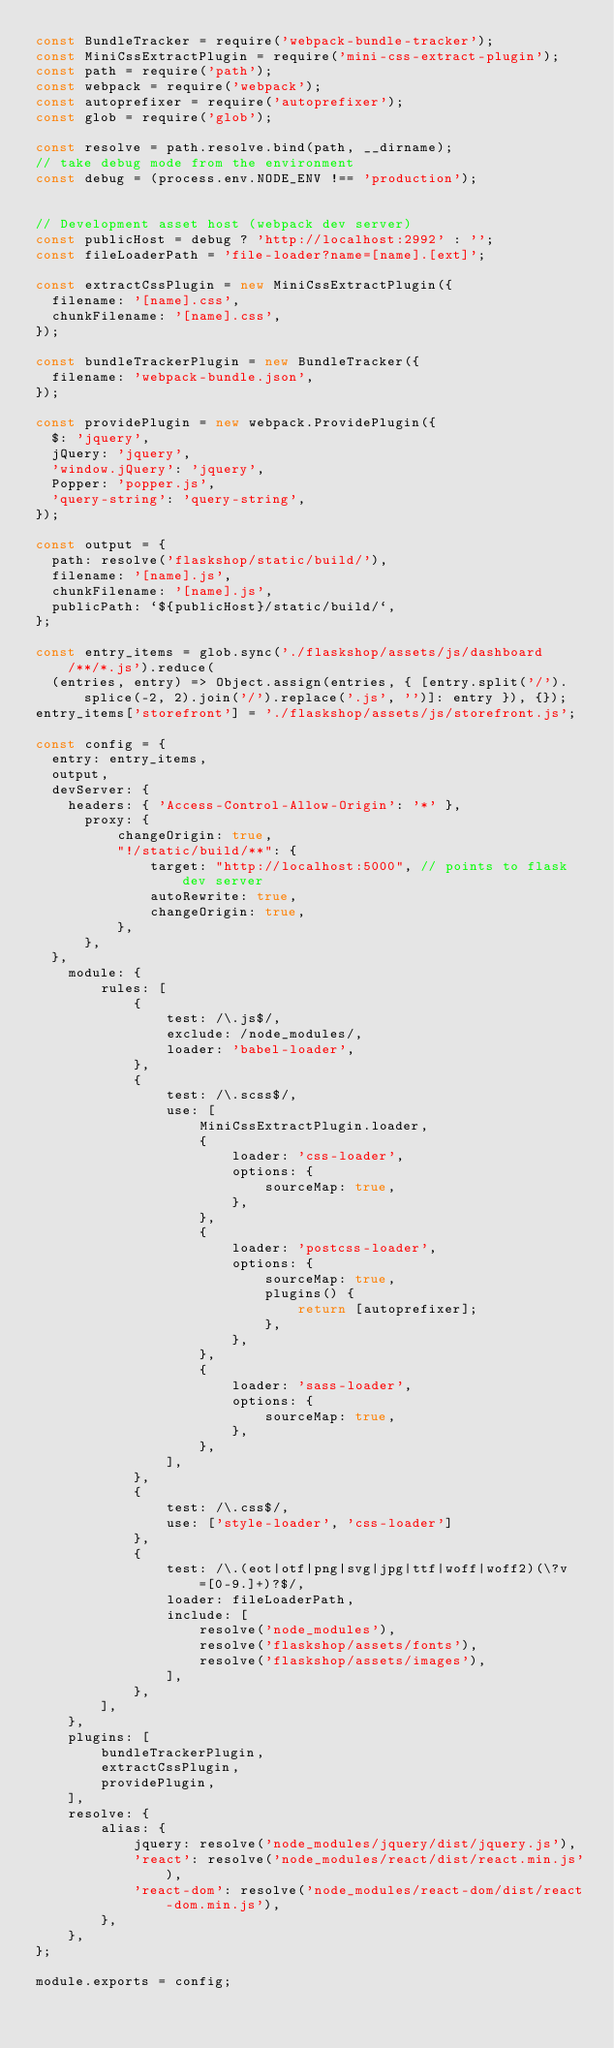Convert code to text. <code><loc_0><loc_0><loc_500><loc_500><_JavaScript_>const BundleTracker = require('webpack-bundle-tracker');
const MiniCssExtractPlugin = require('mini-css-extract-plugin');
const path = require('path');
const webpack = require('webpack');
const autoprefixer = require('autoprefixer');
const glob = require('glob');

const resolve = path.resolve.bind(path, __dirname);
// take debug mode from the environment
const debug = (process.env.NODE_ENV !== 'production');


// Development asset host (webpack dev server)
const publicHost = debug ? 'http://localhost:2992' : '';
const fileLoaderPath = 'file-loader?name=[name].[ext]';

const extractCssPlugin = new MiniCssExtractPlugin({
  filename: '[name].css',
  chunkFilename: '[name].css',
});

const bundleTrackerPlugin = new BundleTracker({
  filename: 'webpack-bundle.json',
});

const providePlugin = new webpack.ProvidePlugin({
  $: 'jquery',
  jQuery: 'jquery',
  'window.jQuery': 'jquery',
  Popper: 'popper.js',
  'query-string': 'query-string',
});

const output = {
  path: resolve('flaskshop/static/build/'),
  filename: '[name].js',
  chunkFilename: '[name].js',
  publicPath: `${publicHost}/static/build/`,
};

const entry_items = glob.sync('./flaskshop/assets/js/dashboard/**/*.js').reduce(
  (entries, entry) => Object.assign(entries, { [entry.split('/').splice(-2, 2).join('/').replace('.js', '')]: entry }), {});
entry_items['storefront'] = './flaskshop/assets/js/storefront.js';

const config = {
  entry: entry_items,
  output,
  devServer: {
    headers: { 'Access-Control-Allow-Origin': '*' },
      proxy: {
          changeOrigin: true,
          "!/static/build/**": {
              target: "http://localhost:5000", // points to flask dev server
              autoRewrite: true,
              changeOrigin: true,
          },
      },
  },
    module: {
        rules: [
            {
                test: /\.js$/,
                exclude: /node_modules/,
                loader: 'babel-loader',
            },
            {
                test: /\.scss$/,
                use: [
                    MiniCssExtractPlugin.loader,
                    {
                        loader: 'css-loader',
                        options: {
                            sourceMap: true,
                        },
                    },
                    {
                        loader: 'postcss-loader',
                        options: {
                            sourceMap: true,
                            plugins() {
                                return [autoprefixer];
                            },
                        },
                    },
                    {
                        loader: 'sass-loader',
                        options: {
                            sourceMap: true,
                        },
                    },
                ],
            },
            {
                test: /\.css$/,
                use: ['style-loader', 'css-loader']
            },
            {
                test: /\.(eot|otf|png|svg|jpg|ttf|woff|woff2)(\?v=[0-9.]+)?$/,
                loader: fileLoaderPath,
                include: [
                    resolve('node_modules'),
                    resolve('flaskshop/assets/fonts'),
                    resolve('flaskshop/assets/images'),
                ],
            },
        ],
    },
    plugins: [
        bundleTrackerPlugin,
        extractCssPlugin,
        providePlugin,
    ],
    resolve: {
        alias: {
            jquery: resolve('node_modules/jquery/dist/jquery.js'),
            'react': resolve('node_modules/react/dist/react.min.js'),
            'react-dom': resolve('node_modules/react-dom/dist/react-dom.min.js'),
        },
    },
};

module.exports = config;

</code> 